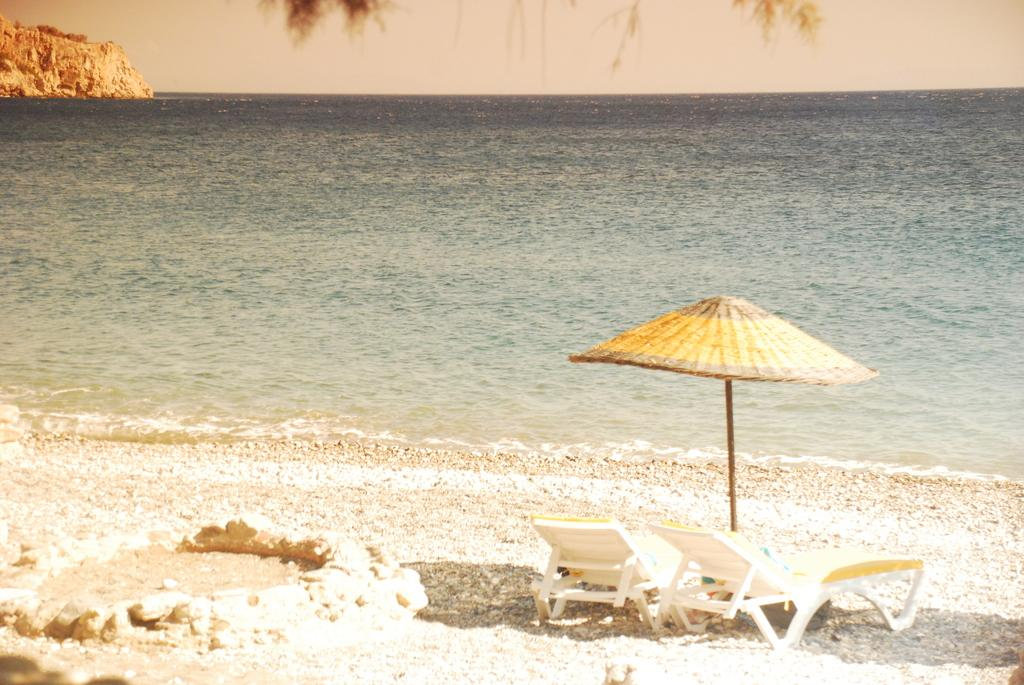What type of furniture is present in the image? There are beach chairs in the image. What is providing shade in the image? There is an umbrella in the image. Where are the beach chairs and umbrella located? The beach chairs and umbrella are on the sea shore. What can be seen besides the beach chairs and umbrella? There is water visible in the image. What is visible in the background of the image? The sky is visible in the background of the image. What type of pen is being used to write in the sand in the image? There is no pen or writing in the sand present in the image. What activity is the expansion of the beach chairs and umbrella involved in? The beach chairs and umbrella are not expanding or involved in any activity; they are stationary in the image. 